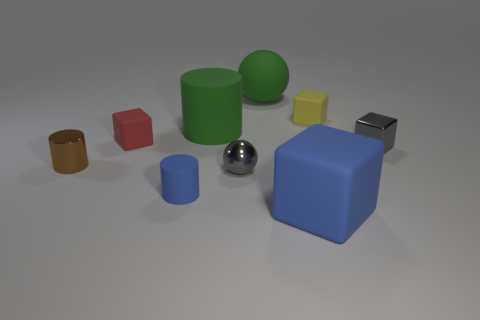What material is the small block that is the same color as the metallic ball?
Your answer should be very brief. Metal. Are there any other things that have the same shape as the red rubber object?
Keep it short and to the point. Yes. How many things are either tiny objects to the left of the tiny yellow rubber thing or tiny yellow cubes?
Provide a succinct answer. 5. Do the small matte object in front of the small metallic block and the matte sphere have the same color?
Provide a short and direct response. No. There is a small matte object in front of the tiny gray shiny object that is behind the tiny brown cylinder; what shape is it?
Keep it short and to the point. Cylinder. Is the number of matte objects behind the yellow rubber thing less than the number of tiny matte cylinders that are behind the tiny gray ball?
Your response must be concise. No. What is the size of the blue rubber object that is the same shape as the small yellow matte object?
Give a very brief answer. Large. Are there any other things that are the same size as the blue cube?
Offer a terse response. Yes. What number of things are tiny matte objects on the left side of the large blue object or tiny yellow rubber blocks left of the gray cube?
Make the answer very short. 3. Is the size of the brown metal thing the same as the green sphere?
Your answer should be very brief. No. 